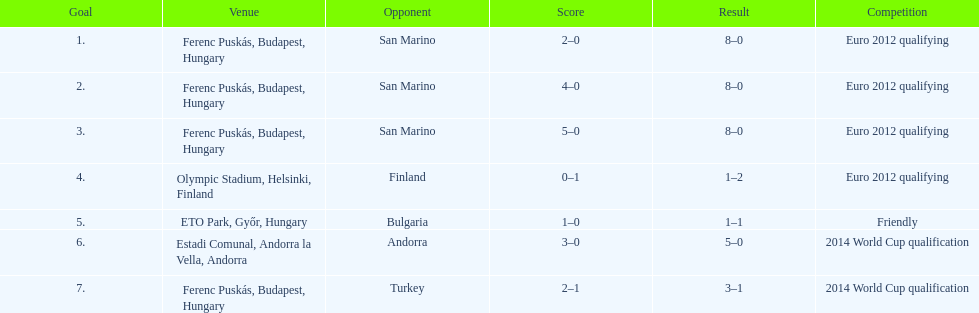What is the cumulative number of international goals ádám szalai has scored? 7. 